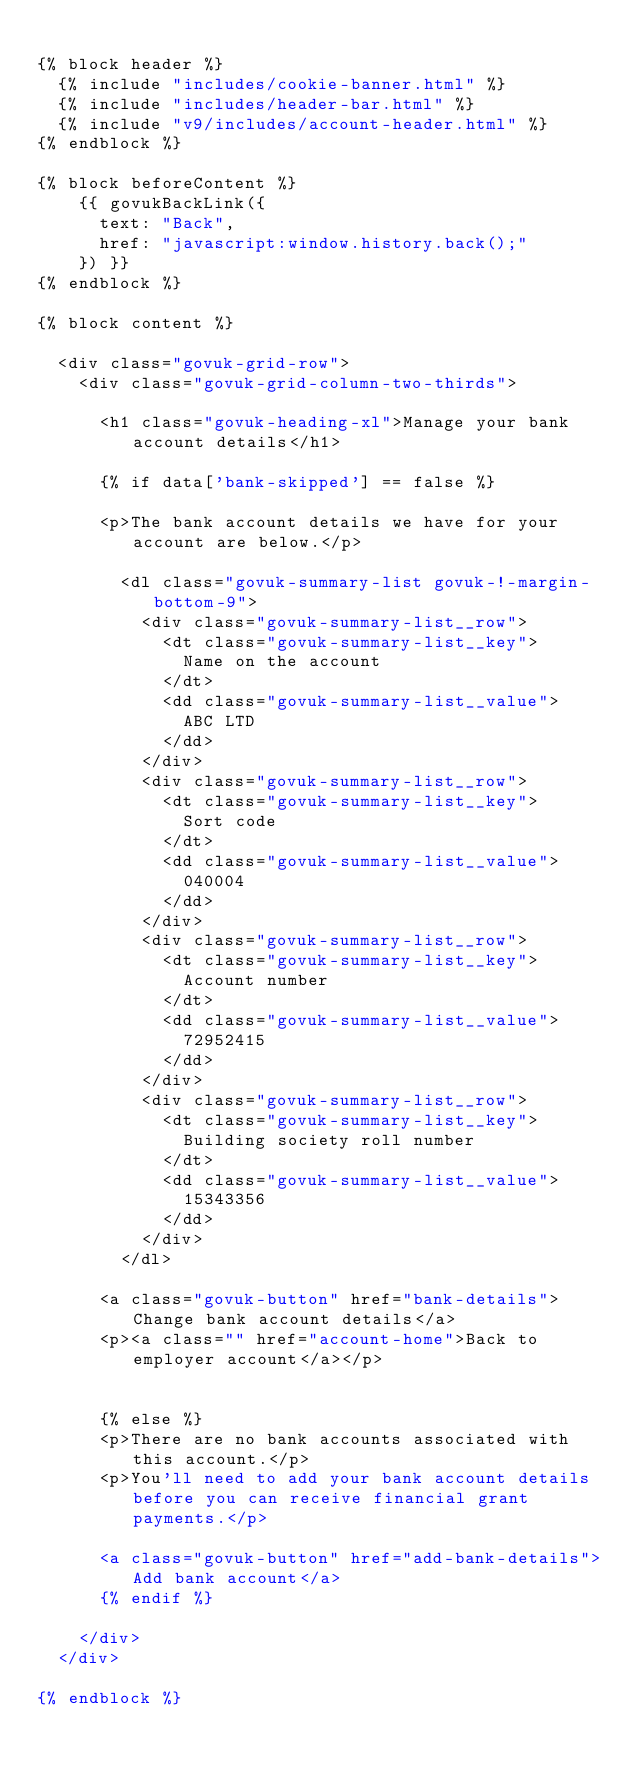<code> <loc_0><loc_0><loc_500><loc_500><_HTML_>
{% block header %}
  {% include "includes/cookie-banner.html" %}
  {% include "includes/header-bar.html" %}
  {% include "v9/includes/account-header.html" %}
{% endblock %}

{% block beforeContent %}
    {{ govukBackLink({
      text: "Back",
      href: "javascript:window.history.back();"
    }) }}
{% endblock %}

{% block content %}

  <div class="govuk-grid-row">
    <div class="govuk-grid-column-two-thirds">

      <h1 class="govuk-heading-xl">Manage your bank account details</h1>

      {% if data['bank-skipped'] == false %}

      <p>The bank account details we have for your account are below.</p>

        <dl class="govuk-summary-list govuk-!-margin-bottom-9">
          <div class="govuk-summary-list__row">
            <dt class="govuk-summary-list__key">
              Name on the account
            </dt>
            <dd class="govuk-summary-list__value">
              ABC LTD
            </dd>
          </div>
          <div class="govuk-summary-list__row">
            <dt class="govuk-summary-list__key">
              Sort code
            </dt>
            <dd class="govuk-summary-list__value">
              040004
            </dd>
          </div>
          <div class="govuk-summary-list__row">
            <dt class="govuk-summary-list__key">
              Account number
            </dt>
            <dd class="govuk-summary-list__value">
              72952415
            </dd>
          </div>
          <div class="govuk-summary-list__row">
            <dt class="govuk-summary-list__key">
              Building society roll number
            </dt>
            <dd class="govuk-summary-list__value">
              15343356
            </dd>
          </div>
        </dl>

      <a class="govuk-button" href="bank-details">Change bank account details</a>
      <p><a class="" href="account-home">Back to employer account</a></p>


      {% else %}
      <p>There are no bank accounts associated with this account.</p>
      <p>You'll need to add your bank account details before you can receive financial grant payments.</p>

      <a class="govuk-button" href="add-bank-details">Add bank account</a>
      {% endif %}

    </div>
  </div>

{% endblock %}
</code> 